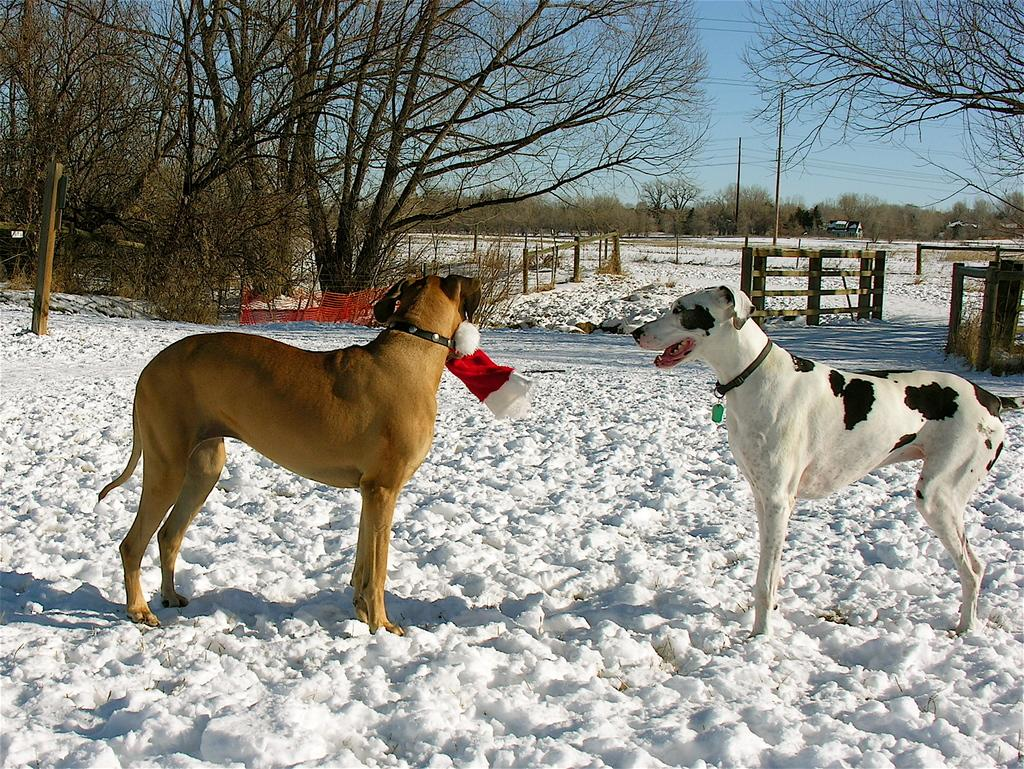How many dogs are in the image? There are two dogs in the image. What is the surface the dogs are standing on? The dogs are standing on the snow. What can be seen in the background of the image? There are trees, poles, and vehicles in the background of the image. What is visible at the top of the image? The sky is visible at the top of the image. What type of bean is being played in harmony by the dogs in the image? There is no bean or musical instrument present in the image, and the dogs are not playing anything. 